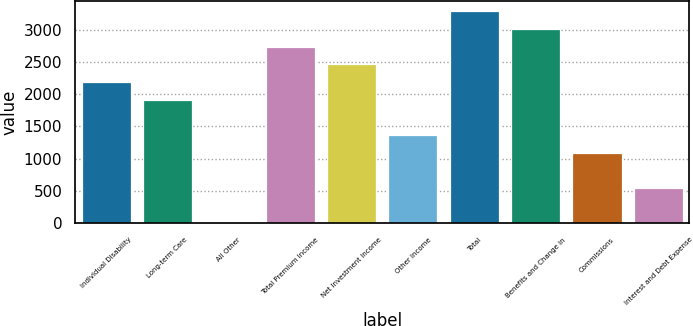Convert chart to OTSL. <chart><loc_0><loc_0><loc_500><loc_500><bar_chart><fcel>Individual Disability<fcel>Long-term Care<fcel>All Other<fcel>Total Premium Income<fcel>Net Investment Income<fcel>Other Income<fcel>Total<fcel>Benefits and Change in<fcel>Commissions<fcel>Interest and Debt Expense<nl><fcel>2187.58<fcel>1914.47<fcel>2.7<fcel>2733.8<fcel>2460.69<fcel>1368.25<fcel>3280.02<fcel>3006.91<fcel>1095.14<fcel>548.92<nl></chart> 